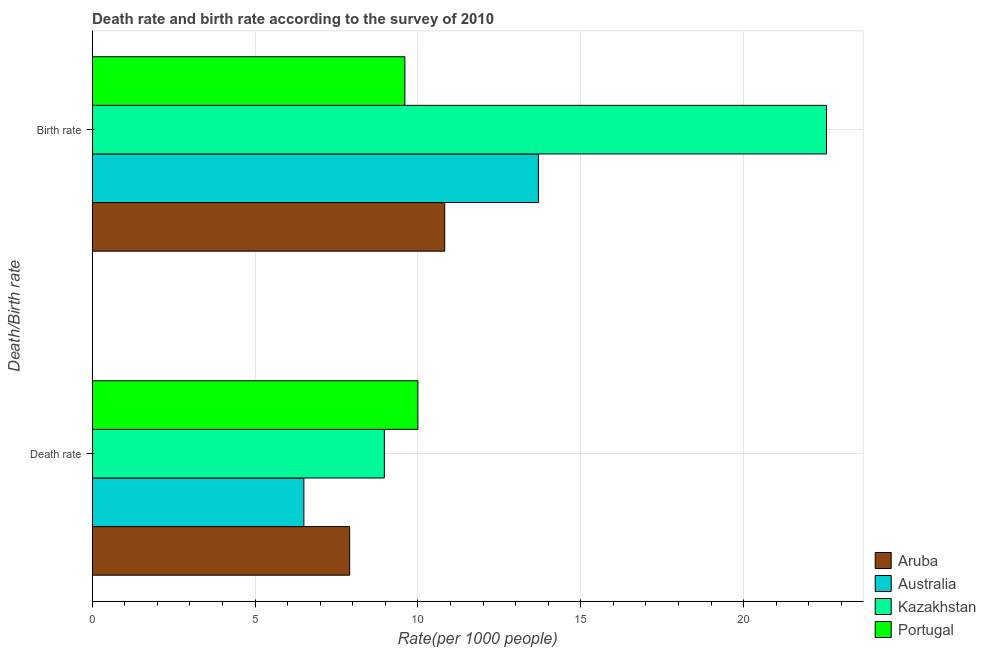How many groups of bars are there?
Provide a succinct answer. 2. Are the number of bars per tick equal to the number of legend labels?
Your response must be concise. Yes. How many bars are there on the 2nd tick from the bottom?
Your response must be concise. 4. What is the label of the 2nd group of bars from the top?
Provide a succinct answer. Death rate. What is the death rate in Kazakhstan?
Offer a terse response. 8.97. Across all countries, what is the maximum birth rate?
Ensure brevity in your answer.  22.54. Across all countries, what is the minimum death rate?
Provide a succinct answer. 6.5. In which country was the birth rate maximum?
Your answer should be very brief. Kazakhstan. In which country was the birth rate minimum?
Offer a very short reply. Portugal. What is the total birth rate in the graph?
Your response must be concise. 56.66. What is the difference between the birth rate in Portugal and that in Kazakhstan?
Offer a very short reply. -12.94. What is the difference between the birth rate in Aruba and the death rate in Portugal?
Provide a succinct answer. 0.82. What is the average birth rate per country?
Provide a succinct answer. 14.17. What is the difference between the death rate and birth rate in Aruba?
Ensure brevity in your answer.  -2.92. In how many countries, is the birth rate greater than 19 ?
Your response must be concise. 1. What is the ratio of the death rate in Aruba to that in Australia?
Your response must be concise. 1.22. Is the death rate in Aruba less than that in Australia?
Keep it short and to the point. No. In how many countries, is the death rate greater than the average death rate taken over all countries?
Make the answer very short. 2. What does the 1st bar from the bottom in Death rate represents?
Give a very brief answer. Aruba. How many bars are there?
Give a very brief answer. 8. Does the graph contain grids?
Provide a short and direct response. Yes. How many legend labels are there?
Keep it short and to the point. 4. What is the title of the graph?
Ensure brevity in your answer.  Death rate and birth rate according to the survey of 2010. What is the label or title of the X-axis?
Offer a very short reply. Rate(per 1000 people). What is the label or title of the Y-axis?
Your response must be concise. Death/Birth rate. What is the Rate(per 1000 people) of Aruba in Death rate?
Make the answer very short. 7.91. What is the Rate(per 1000 people) of Australia in Death rate?
Your answer should be compact. 6.5. What is the Rate(per 1000 people) of Kazakhstan in Death rate?
Your answer should be compact. 8.97. What is the Rate(per 1000 people) in Aruba in Birth rate?
Your response must be concise. 10.82. What is the Rate(per 1000 people) of Kazakhstan in Birth rate?
Your response must be concise. 22.54. What is the Rate(per 1000 people) in Portugal in Birth rate?
Ensure brevity in your answer.  9.6. Across all Death/Birth rate, what is the maximum Rate(per 1000 people) in Aruba?
Ensure brevity in your answer.  10.82. Across all Death/Birth rate, what is the maximum Rate(per 1000 people) of Kazakhstan?
Provide a short and direct response. 22.54. Across all Death/Birth rate, what is the maximum Rate(per 1000 people) of Portugal?
Your answer should be compact. 10. Across all Death/Birth rate, what is the minimum Rate(per 1000 people) of Aruba?
Provide a succinct answer. 7.91. Across all Death/Birth rate, what is the minimum Rate(per 1000 people) of Australia?
Your answer should be very brief. 6.5. Across all Death/Birth rate, what is the minimum Rate(per 1000 people) in Kazakhstan?
Give a very brief answer. 8.97. Across all Death/Birth rate, what is the minimum Rate(per 1000 people) in Portugal?
Your answer should be compact. 9.6. What is the total Rate(per 1000 people) of Aruba in the graph?
Provide a succinct answer. 18.73. What is the total Rate(per 1000 people) in Australia in the graph?
Your answer should be compact. 20.2. What is the total Rate(per 1000 people) of Kazakhstan in the graph?
Offer a terse response. 31.51. What is the total Rate(per 1000 people) in Portugal in the graph?
Your answer should be very brief. 19.6. What is the difference between the Rate(per 1000 people) in Aruba in Death rate and that in Birth rate?
Your answer should be very brief. -2.92. What is the difference between the Rate(per 1000 people) of Kazakhstan in Death rate and that in Birth rate?
Make the answer very short. -13.57. What is the difference between the Rate(per 1000 people) in Aruba in Death rate and the Rate(per 1000 people) in Australia in Birth rate?
Your answer should be compact. -5.79. What is the difference between the Rate(per 1000 people) of Aruba in Death rate and the Rate(per 1000 people) of Kazakhstan in Birth rate?
Your response must be concise. -14.63. What is the difference between the Rate(per 1000 people) in Aruba in Death rate and the Rate(per 1000 people) in Portugal in Birth rate?
Give a very brief answer. -1.7. What is the difference between the Rate(per 1000 people) of Australia in Death rate and the Rate(per 1000 people) of Kazakhstan in Birth rate?
Your answer should be compact. -16.04. What is the difference between the Rate(per 1000 people) in Australia in Death rate and the Rate(per 1000 people) in Portugal in Birth rate?
Ensure brevity in your answer.  -3.1. What is the difference between the Rate(per 1000 people) of Kazakhstan in Death rate and the Rate(per 1000 people) of Portugal in Birth rate?
Your answer should be very brief. -0.63. What is the average Rate(per 1000 people) of Aruba per Death/Birth rate?
Offer a terse response. 9.36. What is the average Rate(per 1000 people) of Australia per Death/Birth rate?
Your response must be concise. 10.1. What is the average Rate(per 1000 people) in Kazakhstan per Death/Birth rate?
Ensure brevity in your answer.  15.76. What is the difference between the Rate(per 1000 people) of Aruba and Rate(per 1000 people) of Australia in Death rate?
Your answer should be very brief. 1.41. What is the difference between the Rate(per 1000 people) of Aruba and Rate(per 1000 people) of Kazakhstan in Death rate?
Your response must be concise. -1.06. What is the difference between the Rate(per 1000 people) in Aruba and Rate(per 1000 people) in Portugal in Death rate?
Your answer should be very brief. -2.1. What is the difference between the Rate(per 1000 people) in Australia and Rate(per 1000 people) in Kazakhstan in Death rate?
Provide a succinct answer. -2.47. What is the difference between the Rate(per 1000 people) in Australia and Rate(per 1000 people) in Portugal in Death rate?
Offer a very short reply. -3.5. What is the difference between the Rate(per 1000 people) in Kazakhstan and Rate(per 1000 people) in Portugal in Death rate?
Give a very brief answer. -1.03. What is the difference between the Rate(per 1000 people) of Aruba and Rate(per 1000 people) of Australia in Birth rate?
Provide a short and direct response. -2.88. What is the difference between the Rate(per 1000 people) in Aruba and Rate(per 1000 people) in Kazakhstan in Birth rate?
Provide a short and direct response. -11.72. What is the difference between the Rate(per 1000 people) of Aruba and Rate(per 1000 people) of Portugal in Birth rate?
Your answer should be very brief. 1.22. What is the difference between the Rate(per 1000 people) of Australia and Rate(per 1000 people) of Kazakhstan in Birth rate?
Offer a terse response. -8.84. What is the difference between the Rate(per 1000 people) in Kazakhstan and Rate(per 1000 people) in Portugal in Birth rate?
Your answer should be very brief. 12.94. What is the ratio of the Rate(per 1000 people) of Aruba in Death rate to that in Birth rate?
Your answer should be very brief. 0.73. What is the ratio of the Rate(per 1000 people) in Australia in Death rate to that in Birth rate?
Offer a terse response. 0.47. What is the ratio of the Rate(per 1000 people) in Kazakhstan in Death rate to that in Birth rate?
Give a very brief answer. 0.4. What is the ratio of the Rate(per 1000 people) of Portugal in Death rate to that in Birth rate?
Keep it short and to the point. 1.04. What is the difference between the highest and the second highest Rate(per 1000 people) in Aruba?
Offer a terse response. 2.92. What is the difference between the highest and the second highest Rate(per 1000 people) in Kazakhstan?
Offer a terse response. 13.57. What is the difference between the highest and the second highest Rate(per 1000 people) of Portugal?
Give a very brief answer. 0.4. What is the difference between the highest and the lowest Rate(per 1000 people) of Aruba?
Your response must be concise. 2.92. What is the difference between the highest and the lowest Rate(per 1000 people) of Kazakhstan?
Offer a very short reply. 13.57. What is the difference between the highest and the lowest Rate(per 1000 people) of Portugal?
Your response must be concise. 0.4. 